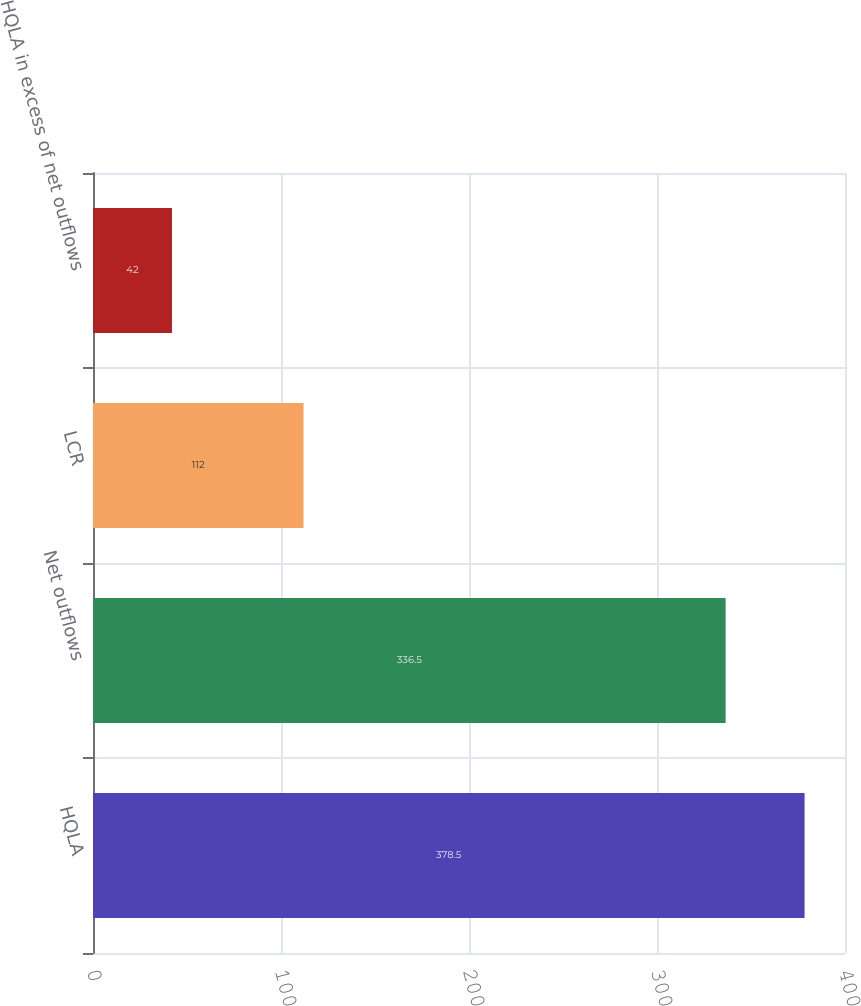Convert chart to OTSL. <chart><loc_0><loc_0><loc_500><loc_500><bar_chart><fcel>HQLA<fcel>Net outflows<fcel>LCR<fcel>HQLA in excess of net outflows<nl><fcel>378.5<fcel>336.5<fcel>112<fcel>42<nl></chart> 